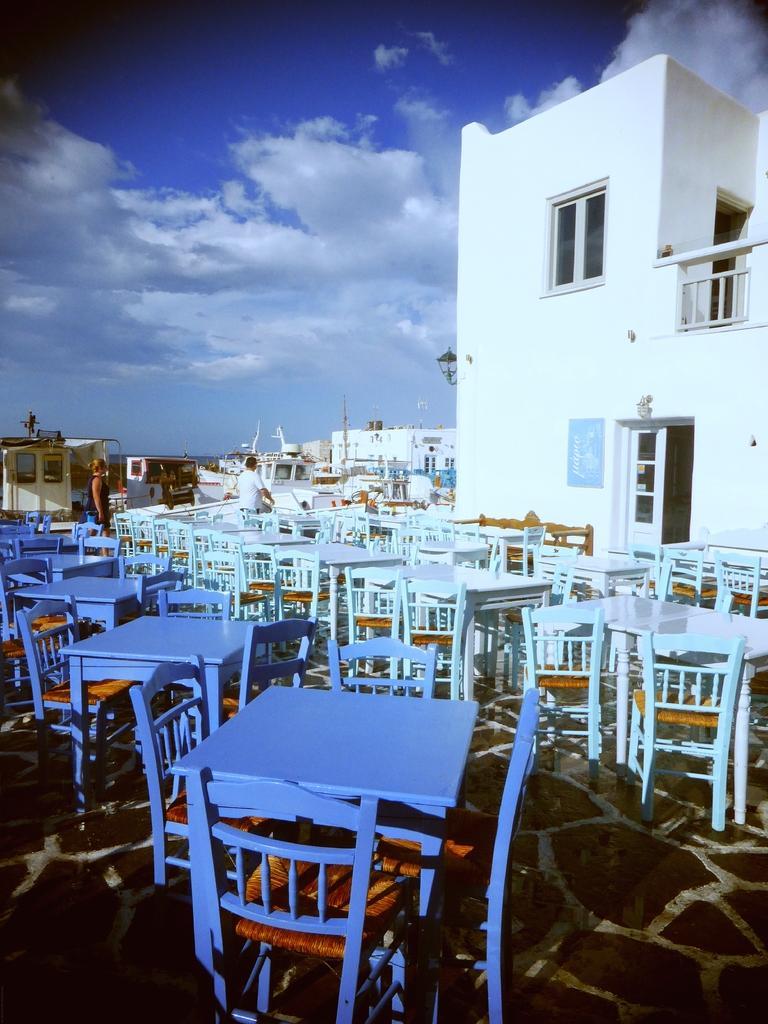Describe this image in one or two sentences. In this image few chairs and tables are on the floor. Behind there are two persons standing. Right side there is a lamp attached to the wall of a building having windows and door. Background there are few buildings. Top of the image there is sky with some clouds. 